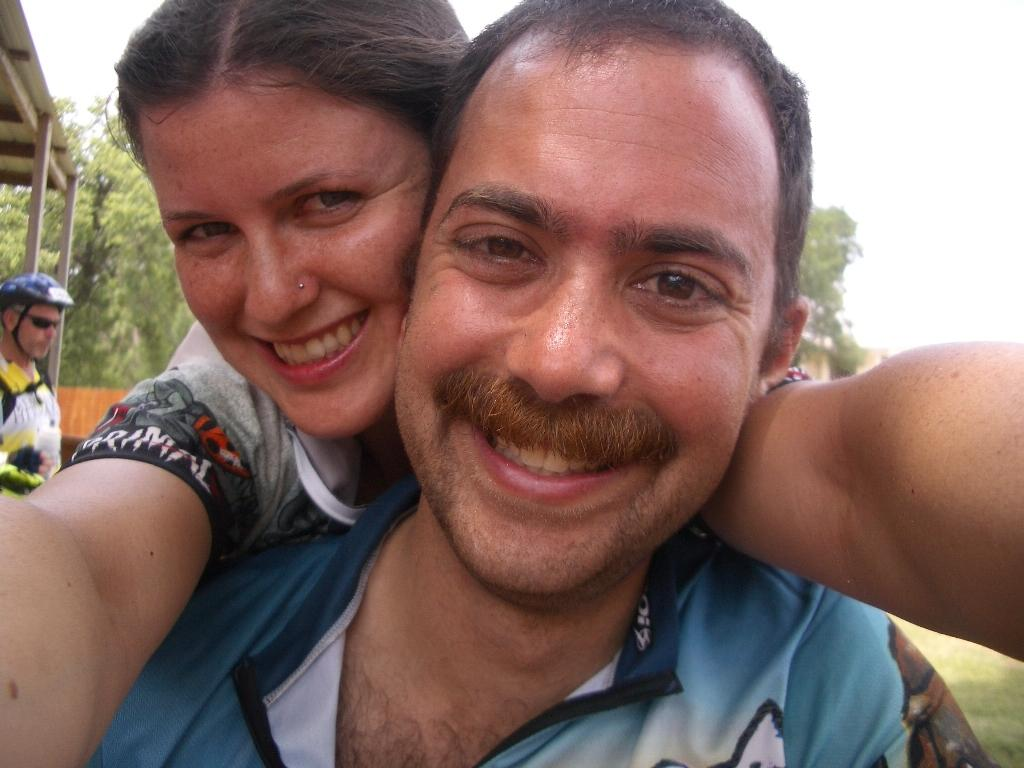Who are the people in the center of the image? There is a man and a woman in the center of the image. Can you describe the man on the left side of the image? There is a man on the left side of the image. What can be seen in the background of the image? There are trees and the sky visible in the background of the image. What type of grape is the man on the left side of the image eating? There is no grape present in the image, and therefore no such activity can be observed. 